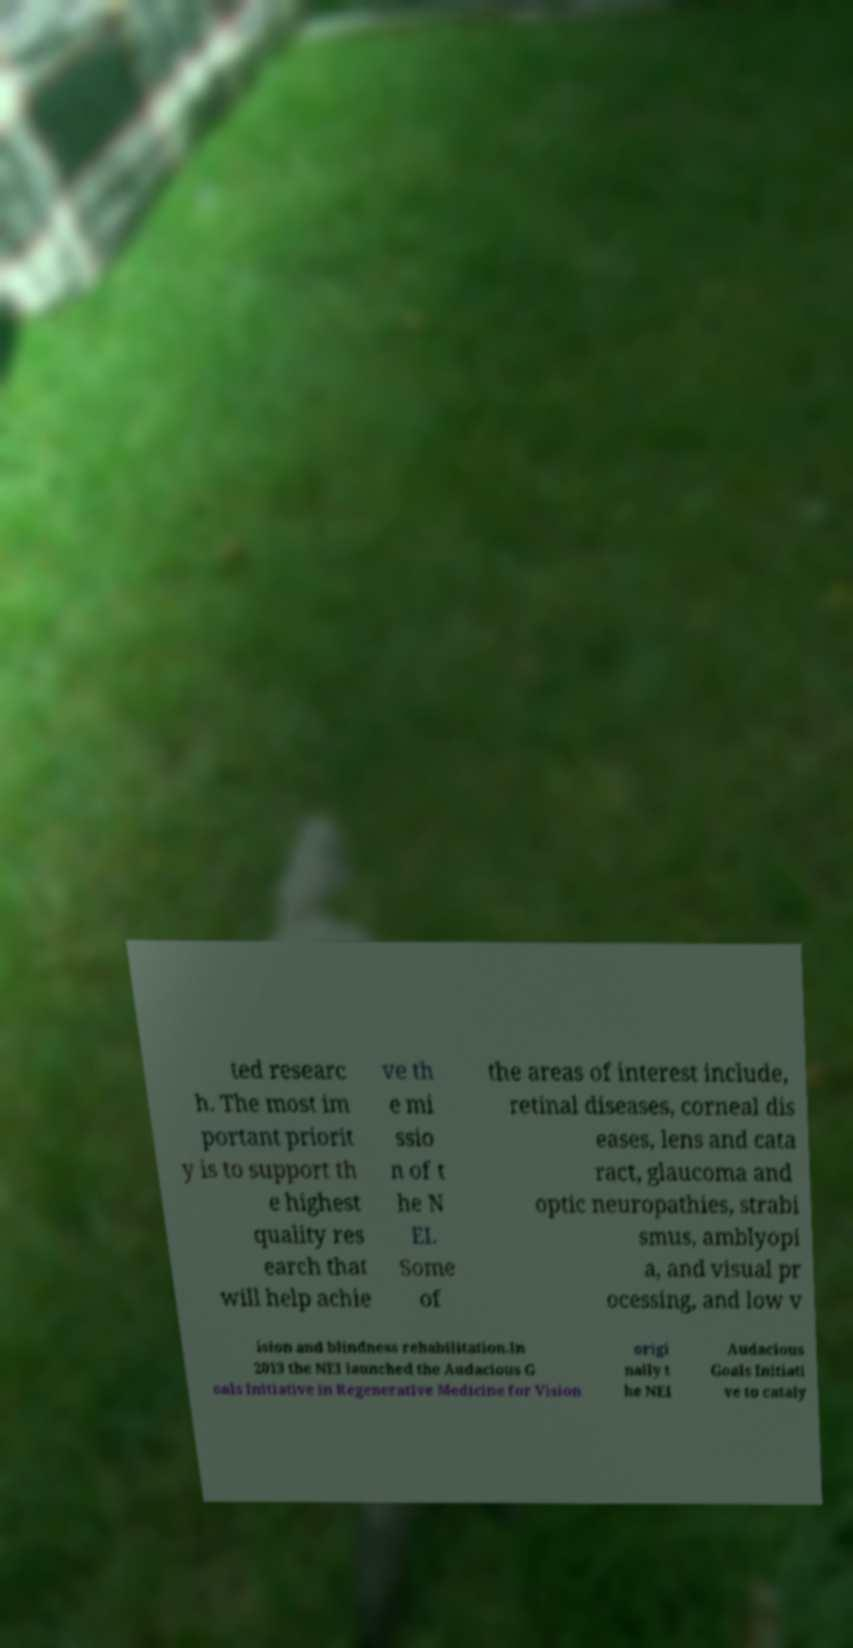Please read and relay the text visible in this image. What does it say? ted researc h. The most im portant priorit y is to support th e highest quality res earch that will help achie ve th e mi ssio n of t he N EI. Some of the areas of interest include, retinal diseases, corneal dis eases, lens and cata ract, glaucoma and optic neuropathies, strabi smus, amblyopi a, and visual pr ocessing, and low v ision and blindness rehabilitation.In 2013 the NEI launched the Audacious G oals Initiative in Regenerative Medicine for Vision origi nally t he NEI Audacious Goals Initiati ve to cataly 